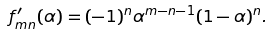<formula> <loc_0><loc_0><loc_500><loc_500>f ^ { \prime } _ { m n } ( \alpha ) = ( - 1 ) ^ { n } \alpha ^ { m - n - 1 } ( 1 - \alpha ) ^ { n } .</formula> 